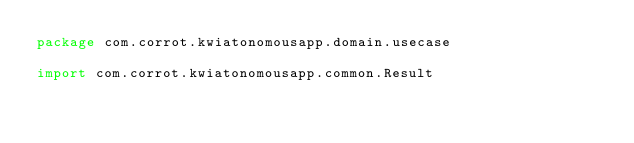<code> <loc_0><loc_0><loc_500><loc_500><_Kotlin_>package com.corrot.kwiatonomousapp.domain.usecase

import com.corrot.kwiatonomousapp.common.Result</code> 